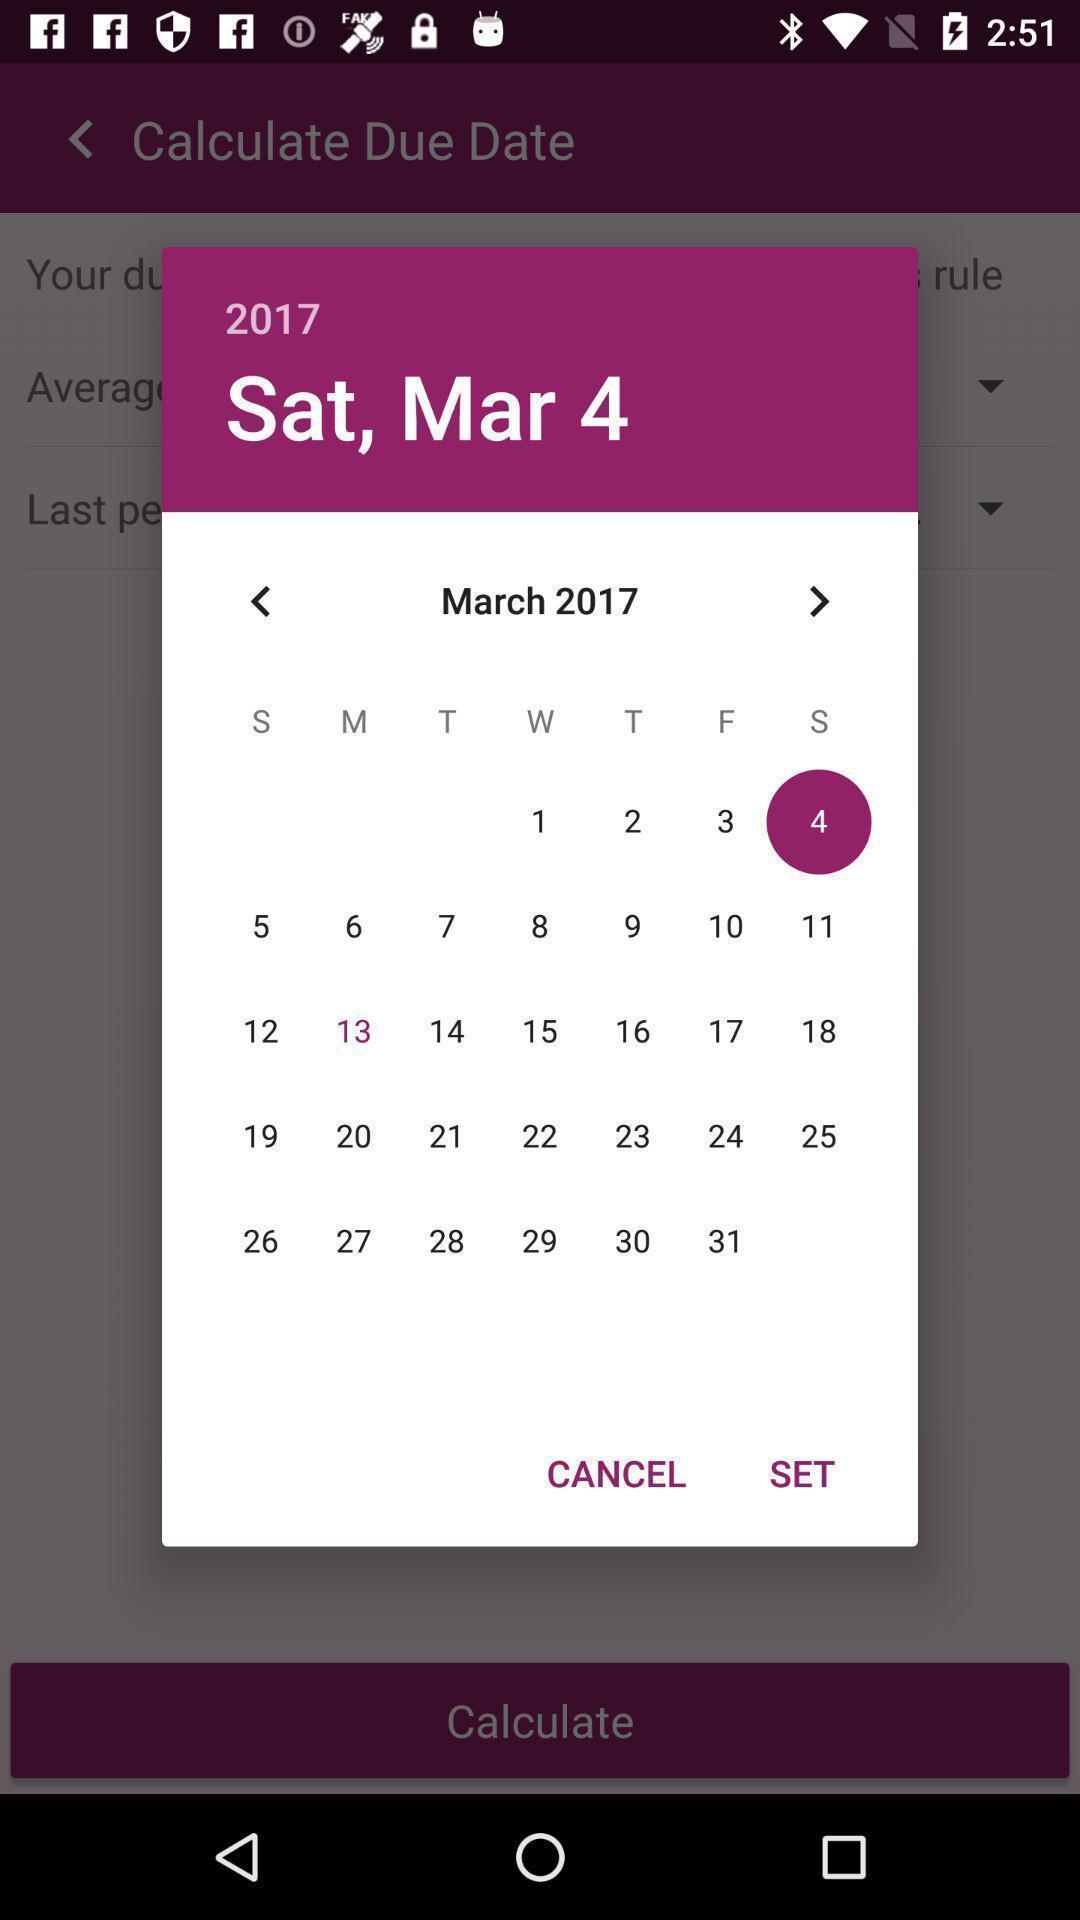Summarize the main components in this picture. Pop-up showing calendar. 